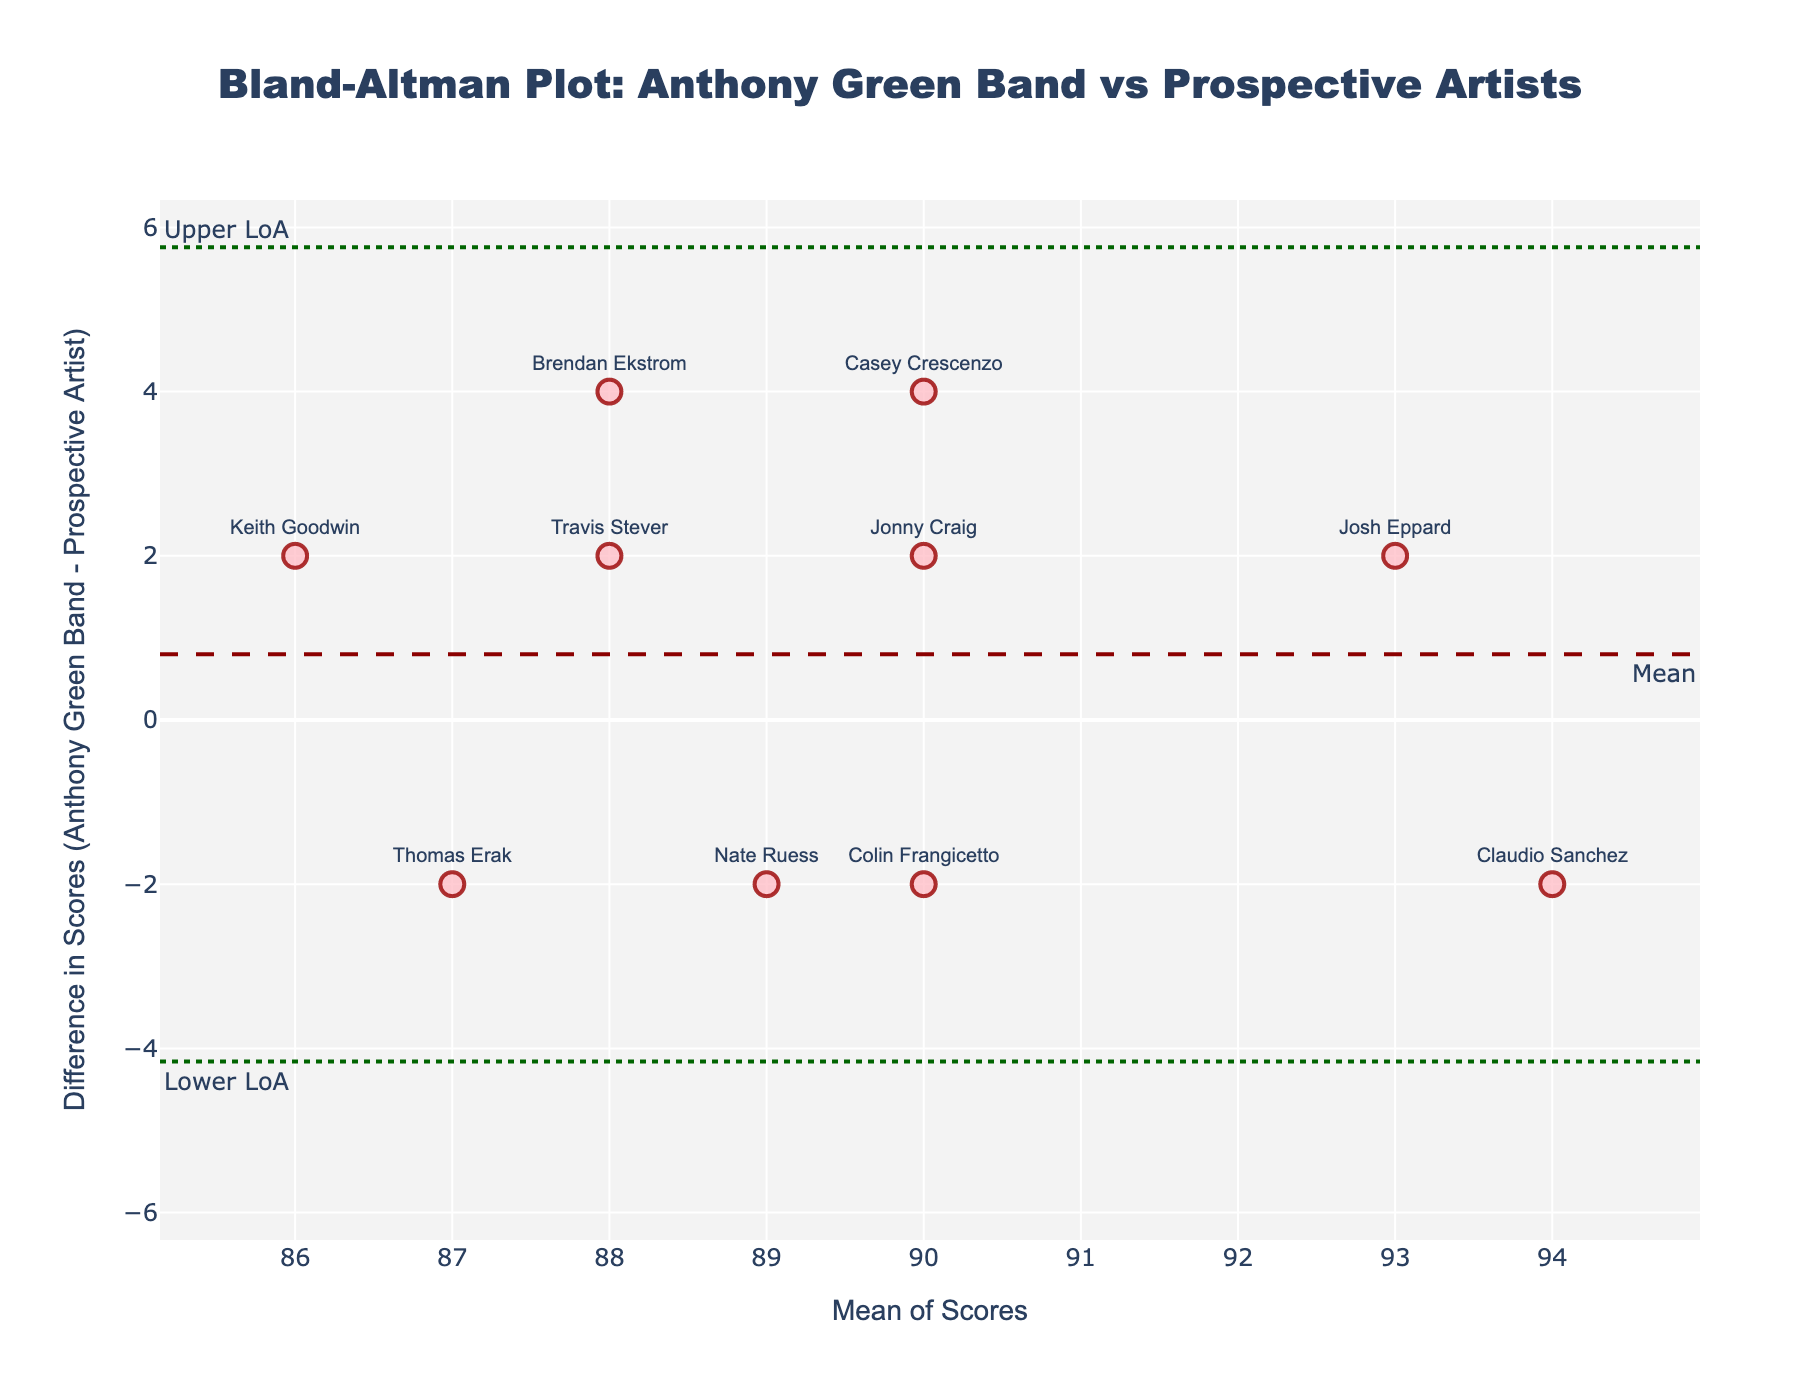What is the title of the figure? The title is usually located at the top center of the plot. It summarizes the overall purpose or subject of the visual representation. The title of this plot is explicitly stated within the plot.
Answer: Bland-Altman Plot: Anthony Green Band vs Prospective Artists How many data points are represented in the plot? By counting the markers on the plot, we can determine the number of data points. Each musician's score comparison appears as one marker on the plot, representing a total number of data points.
Answer: 10 What color are the markers used to represent the data points? The color of the markers is visually evident. Simply observe the marker color used throughout the plot.
Answer: Pink What does the dashed horizontal line represent? The dashed horizontal line indicates a specific value in the plot, labeled with an annotation text. By referring to the annotation, one can understand its representation.
Answer: Mean What does the difference in scores indicate about the performance comparison between Anthony Green's band members and the prospective artists? The difference in scores is the vertical distance between 0 and the actual data points. A positive difference indicates Anthony Green's band member outperformed the prospective artist, while a negative difference indicates the opposite.
Answer: Performance comparison How many data points fall above the mean difference line? Count the number of markers located above the dashed mean difference horizontal line. This will give the number of data points with positive differences.
Answer: 6 Which musician has the highest mean score, and what is the value? Calculate the mean score for each musician and identify the highest one. The mean score is the average of the Anthony Green Band Score and the Prospective Artist Score for each musician. Claudio Sanchez has the highest mean score of 94.
Answer: Claudio Sanchez; 94 Which musician has the largest absolute difference in scores, and what is that difference? Calculate the absolute difference (ignoring the sign) between the Anthony Green Band Score and the Prospective Artist Score for each musician, then identify the largest one. Brendan Ekstrom has the largest absolute difference of 4.
Answer: Brendan Ekstrom; 4 What are the limits of agreement, and what do they represent? The limits of agreement are represented by the dotted horizontal lines, indicating the range within which 95% of the differences between the scores lie. These are displayed with annotations.
Answer: -3.07 and 3.07 How does the mean difference help in understanding the overall agreement between Anthony Green Band scores and Prospective Artist scores? The mean difference line shows how close the scores from Anthony Green Band and prospective artist are on average. A mean difference of 0 would indicate perfect agreement. The mean difference is also used to calculate the limits of agreement.
Answer: Indicates overall bias 